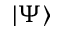Convert formula to latex. <formula><loc_0><loc_0><loc_500><loc_500>\left | { \Psi } \right \rangle</formula> 